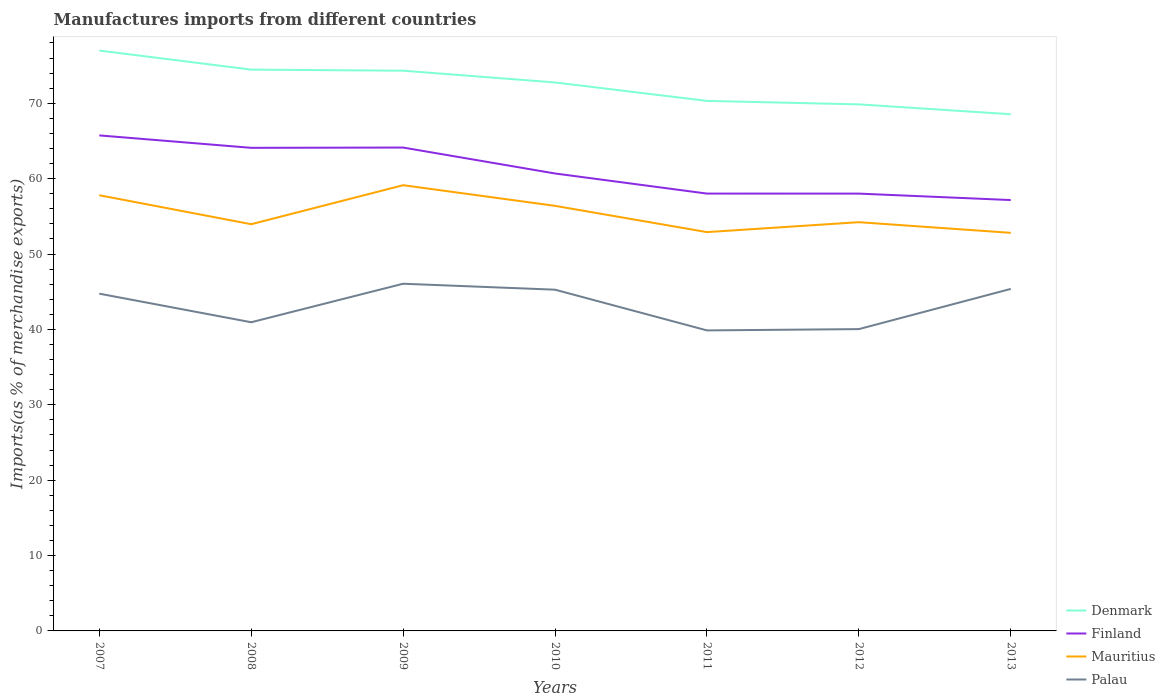Does the line corresponding to Denmark intersect with the line corresponding to Finland?
Provide a short and direct response. No. Across all years, what is the maximum percentage of imports to different countries in Denmark?
Your response must be concise. 68.54. What is the total percentage of imports to different countries in Palau in the graph?
Your answer should be compact. -5.11. What is the difference between the highest and the second highest percentage of imports to different countries in Finland?
Your response must be concise. 8.58. What is the difference between the highest and the lowest percentage of imports to different countries in Palau?
Make the answer very short. 4. Is the percentage of imports to different countries in Finland strictly greater than the percentage of imports to different countries in Mauritius over the years?
Provide a succinct answer. No. What is the difference between two consecutive major ticks on the Y-axis?
Offer a terse response. 10. Are the values on the major ticks of Y-axis written in scientific E-notation?
Offer a terse response. No. Does the graph contain grids?
Make the answer very short. No. How many legend labels are there?
Make the answer very short. 4. What is the title of the graph?
Provide a succinct answer. Manufactures imports from different countries. Does "Monaco" appear as one of the legend labels in the graph?
Offer a terse response. No. What is the label or title of the X-axis?
Your answer should be very brief. Years. What is the label or title of the Y-axis?
Your answer should be compact. Imports(as % of merchandise exports). What is the Imports(as % of merchandise exports) of Denmark in 2007?
Ensure brevity in your answer.  76.99. What is the Imports(as % of merchandise exports) in Finland in 2007?
Your answer should be very brief. 65.73. What is the Imports(as % of merchandise exports) in Mauritius in 2007?
Offer a terse response. 57.8. What is the Imports(as % of merchandise exports) of Palau in 2007?
Your response must be concise. 44.74. What is the Imports(as % of merchandise exports) in Denmark in 2008?
Ensure brevity in your answer.  74.46. What is the Imports(as % of merchandise exports) of Finland in 2008?
Ensure brevity in your answer.  64.08. What is the Imports(as % of merchandise exports) of Mauritius in 2008?
Offer a terse response. 53.95. What is the Imports(as % of merchandise exports) of Palau in 2008?
Ensure brevity in your answer.  40.95. What is the Imports(as % of merchandise exports) of Denmark in 2009?
Make the answer very short. 74.32. What is the Imports(as % of merchandise exports) in Finland in 2009?
Ensure brevity in your answer.  64.12. What is the Imports(as % of merchandise exports) in Mauritius in 2009?
Provide a short and direct response. 59.13. What is the Imports(as % of merchandise exports) in Palau in 2009?
Offer a terse response. 46.06. What is the Imports(as % of merchandise exports) in Denmark in 2010?
Your answer should be compact. 72.76. What is the Imports(as % of merchandise exports) of Finland in 2010?
Give a very brief answer. 60.68. What is the Imports(as % of merchandise exports) of Mauritius in 2010?
Offer a terse response. 56.39. What is the Imports(as % of merchandise exports) in Palau in 2010?
Make the answer very short. 45.27. What is the Imports(as % of merchandise exports) in Denmark in 2011?
Provide a succinct answer. 70.31. What is the Imports(as % of merchandise exports) in Finland in 2011?
Your answer should be very brief. 58.02. What is the Imports(as % of merchandise exports) of Mauritius in 2011?
Your answer should be very brief. 52.91. What is the Imports(as % of merchandise exports) in Palau in 2011?
Offer a terse response. 39.87. What is the Imports(as % of merchandise exports) in Denmark in 2012?
Make the answer very short. 69.85. What is the Imports(as % of merchandise exports) of Finland in 2012?
Your answer should be very brief. 58.01. What is the Imports(as % of merchandise exports) in Mauritius in 2012?
Give a very brief answer. 54.22. What is the Imports(as % of merchandise exports) in Palau in 2012?
Your response must be concise. 40.04. What is the Imports(as % of merchandise exports) of Denmark in 2013?
Offer a very short reply. 68.54. What is the Imports(as % of merchandise exports) in Finland in 2013?
Your answer should be compact. 57.16. What is the Imports(as % of merchandise exports) of Mauritius in 2013?
Provide a succinct answer. 52.81. What is the Imports(as % of merchandise exports) of Palau in 2013?
Make the answer very short. 45.37. Across all years, what is the maximum Imports(as % of merchandise exports) in Denmark?
Provide a succinct answer. 76.99. Across all years, what is the maximum Imports(as % of merchandise exports) in Finland?
Keep it short and to the point. 65.73. Across all years, what is the maximum Imports(as % of merchandise exports) of Mauritius?
Your answer should be very brief. 59.13. Across all years, what is the maximum Imports(as % of merchandise exports) of Palau?
Provide a succinct answer. 46.06. Across all years, what is the minimum Imports(as % of merchandise exports) in Denmark?
Your answer should be very brief. 68.54. Across all years, what is the minimum Imports(as % of merchandise exports) of Finland?
Give a very brief answer. 57.16. Across all years, what is the minimum Imports(as % of merchandise exports) of Mauritius?
Make the answer very short. 52.81. Across all years, what is the minimum Imports(as % of merchandise exports) in Palau?
Give a very brief answer. 39.87. What is the total Imports(as % of merchandise exports) of Denmark in the graph?
Offer a terse response. 507.23. What is the total Imports(as % of merchandise exports) in Finland in the graph?
Provide a short and direct response. 427.81. What is the total Imports(as % of merchandise exports) in Mauritius in the graph?
Offer a very short reply. 387.2. What is the total Imports(as % of merchandise exports) of Palau in the graph?
Offer a terse response. 302.28. What is the difference between the Imports(as % of merchandise exports) in Denmark in 2007 and that in 2008?
Your response must be concise. 2.53. What is the difference between the Imports(as % of merchandise exports) of Finland in 2007 and that in 2008?
Ensure brevity in your answer.  1.65. What is the difference between the Imports(as % of merchandise exports) of Mauritius in 2007 and that in 2008?
Offer a terse response. 3.84. What is the difference between the Imports(as % of merchandise exports) of Palau in 2007 and that in 2008?
Offer a terse response. 3.79. What is the difference between the Imports(as % of merchandise exports) in Denmark in 2007 and that in 2009?
Make the answer very short. 2.67. What is the difference between the Imports(as % of merchandise exports) in Finland in 2007 and that in 2009?
Keep it short and to the point. 1.61. What is the difference between the Imports(as % of merchandise exports) of Mauritius in 2007 and that in 2009?
Your answer should be very brief. -1.33. What is the difference between the Imports(as % of merchandise exports) of Palau in 2007 and that in 2009?
Your answer should be very brief. -1.32. What is the difference between the Imports(as % of merchandise exports) in Denmark in 2007 and that in 2010?
Provide a succinct answer. 4.23. What is the difference between the Imports(as % of merchandise exports) in Finland in 2007 and that in 2010?
Keep it short and to the point. 5.05. What is the difference between the Imports(as % of merchandise exports) in Mauritius in 2007 and that in 2010?
Ensure brevity in your answer.  1.41. What is the difference between the Imports(as % of merchandise exports) of Palau in 2007 and that in 2010?
Keep it short and to the point. -0.53. What is the difference between the Imports(as % of merchandise exports) in Denmark in 2007 and that in 2011?
Your answer should be compact. 6.68. What is the difference between the Imports(as % of merchandise exports) of Finland in 2007 and that in 2011?
Give a very brief answer. 7.72. What is the difference between the Imports(as % of merchandise exports) of Mauritius in 2007 and that in 2011?
Make the answer very short. 4.89. What is the difference between the Imports(as % of merchandise exports) of Palau in 2007 and that in 2011?
Give a very brief answer. 4.87. What is the difference between the Imports(as % of merchandise exports) in Denmark in 2007 and that in 2012?
Offer a very short reply. 7.14. What is the difference between the Imports(as % of merchandise exports) of Finland in 2007 and that in 2012?
Offer a terse response. 7.72. What is the difference between the Imports(as % of merchandise exports) in Mauritius in 2007 and that in 2012?
Provide a short and direct response. 3.57. What is the difference between the Imports(as % of merchandise exports) in Palau in 2007 and that in 2012?
Ensure brevity in your answer.  4.7. What is the difference between the Imports(as % of merchandise exports) of Denmark in 2007 and that in 2013?
Provide a short and direct response. 8.45. What is the difference between the Imports(as % of merchandise exports) of Finland in 2007 and that in 2013?
Ensure brevity in your answer.  8.58. What is the difference between the Imports(as % of merchandise exports) of Mauritius in 2007 and that in 2013?
Your answer should be very brief. 4.99. What is the difference between the Imports(as % of merchandise exports) of Palau in 2007 and that in 2013?
Provide a short and direct response. -0.63. What is the difference between the Imports(as % of merchandise exports) in Denmark in 2008 and that in 2009?
Offer a terse response. 0.14. What is the difference between the Imports(as % of merchandise exports) of Finland in 2008 and that in 2009?
Provide a short and direct response. -0.04. What is the difference between the Imports(as % of merchandise exports) of Mauritius in 2008 and that in 2009?
Provide a short and direct response. -5.18. What is the difference between the Imports(as % of merchandise exports) in Palau in 2008 and that in 2009?
Provide a succinct answer. -5.11. What is the difference between the Imports(as % of merchandise exports) in Denmark in 2008 and that in 2010?
Your answer should be compact. 1.7. What is the difference between the Imports(as % of merchandise exports) of Finland in 2008 and that in 2010?
Offer a very short reply. 3.4. What is the difference between the Imports(as % of merchandise exports) in Mauritius in 2008 and that in 2010?
Provide a succinct answer. -2.44. What is the difference between the Imports(as % of merchandise exports) of Palau in 2008 and that in 2010?
Offer a very short reply. -4.32. What is the difference between the Imports(as % of merchandise exports) of Denmark in 2008 and that in 2011?
Your answer should be very brief. 4.15. What is the difference between the Imports(as % of merchandise exports) of Finland in 2008 and that in 2011?
Provide a succinct answer. 6.07. What is the difference between the Imports(as % of merchandise exports) in Mauritius in 2008 and that in 2011?
Your answer should be compact. 1.05. What is the difference between the Imports(as % of merchandise exports) in Palau in 2008 and that in 2011?
Provide a short and direct response. 1.08. What is the difference between the Imports(as % of merchandise exports) in Denmark in 2008 and that in 2012?
Your response must be concise. 4.61. What is the difference between the Imports(as % of merchandise exports) in Finland in 2008 and that in 2012?
Ensure brevity in your answer.  6.07. What is the difference between the Imports(as % of merchandise exports) of Mauritius in 2008 and that in 2012?
Provide a short and direct response. -0.27. What is the difference between the Imports(as % of merchandise exports) of Palau in 2008 and that in 2012?
Provide a short and direct response. 0.91. What is the difference between the Imports(as % of merchandise exports) of Denmark in 2008 and that in 2013?
Your answer should be compact. 5.92. What is the difference between the Imports(as % of merchandise exports) of Finland in 2008 and that in 2013?
Offer a terse response. 6.93. What is the difference between the Imports(as % of merchandise exports) of Mauritius in 2008 and that in 2013?
Ensure brevity in your answer.  1.14. What is the difference between the Imports(as % of merchandise exports) of Palau in 2008 and that in 2013?
Your response must be concise. -4.42. What is the difference between the Imports(as % of merchandise exports) of Denmark in 2009 and that in 2010?
Your response must be concise. 1.56. What is the difference between the Imports(as % of merchandise exports) in Finland in 2009 and that in 2010?
Keep it short and to the point. 3.44. What is the difference between the Imports(as % of merchandise exports) of Mauritius in 2009 and that in 2010?
Provide a succinct answer. 2.74. What is the difference between the Imports(as % of merchandise exports) in Palau in 2009 and that in 2010?
Keep it short and to the point. 0.79. What is the difference between the Imports(as % of merchandise exports) in Denmark in 2009 and that in 2011?
Ensure brevity in your answer.  4.01. What is the difference between the Imports(as % of merchandise exports) of Finland in 2009 and that in 2011?
Offer a terse response. 6.11. What is the difference between the Imports(as % of merchandise exports) of Mauritius in 2009 and that in 2011?
Offer a very short reply. 6.22. What is the difference between the Imports(as % of merchandise exports) of Palau in 2009 and that in 2011?
Make the answer very short. 6.19. What is the difference between the Imports(as % of merchandise exports) of Denmark in 2009 and that in 2012?
Offer a terse response. 4.47. What is the difference between the Imports(as % of merchandise exports) in Finland in 2009 and that in 2012?
Your answer should be compact. 6.11. What is the difference between the Imports(as % of merchandise exports) of Mauritius in 2009 and that in 2012?
Make the answer very short. 4.91. What is the difference between the Imports(as % of merchandise exports) in Palau in 2009 and that in 2012?
Provide a short and direct response. 6.02. What is the difference between the Imports(as % of merchandise exports) in Denmark in 2009 and that in 2013?
Provide a succinct answer. 5.77. What is the difference between the Imports(as % of merchandise exports) of Finland in 2009 and that in 2013?
Make the answer very short. 6.97. What is the difference between the Imports(as % of merchandise exports) in Mauritius in 2009 and that in 2013?
Provide a succinct answer. 6.32. What is the difference between the Imports(as % of merchandise exports) in Palau in 2009 and that in 2013?
Offer a terse response. 0.69. What is the difference between the Imports(as % of merchandise exports) of Denmark in 2010 and that in 2011?
Your answer should be compact. 2.45. What is the difference between the Imports(as % of merchandise exports) in Finland in 2010 and that in 2011?
Your answer should be very brief. 2.67. What is the difference between the Imports(as % of merchandise exports) of Mauritius in 2010 and that in 2011?
Make the answer very short. 3.48. What is the difference between the Imports(as % of merchandise exports) of Palau in 2010 and that in 2011?
Ensure brevity in your answer.  5.4. What is the difference between the Imports(as % of merchandise exports) in Denmark in 2010 and that in 2012?
Offer a terse response. 2.91. What is the difference between the Imports(as % of merchandise exports) in Finland in 2010 and that in 2012?
Offer a very short reply. 2.67. What is the difference between the Imports(as % of merchandise exports) of Mauritius in 2010 and that in 2012?
Keep it short and to the point. 2.17. What is the difference between the Imports(as % of merchandise exports) in Palau in 2010 and that in 2012?
Ensure brevity in your answer.  5.23. What is the difference between the Imports(as % of merchandise exports) in Denmark in 2010 and that in 2013?
Provide a short and direct response. 4.22. What is the difference between the Imports(as % of merchandise exports) of Finland in 2010 and that in 2013?
Give a very brief answer. 3.53. What is the difference between the Imports(as % of merchandise exports) of Mauritius in 2010 and that in 2013?
Give a very brief answer. 3.58. What is the difference between the Imports(as % of merchandise exports) in Palau in 2010 and that in 2013?
Offer a very short reply. -0.1. What is the difference between the Imports(as % of merchandise exports) of Denmark in 2011 and that in 2012?
Provide a short and direct response. 0.46. What is the difference between the Imports(as % of merchandise exports) in Finland in 2011 and that in 2012?
Your answer should be very brief. 0. What is the difference between the Imports(as % of merchandise exports) of Mauritius in 2011 and that in 2012?
Your answer should be compact. -1.32. What is the difference between the Imports(as % of merchandise exports) of Palau in 2011 and that in 2012?
Provide a succinct answer. -0.17. What is the difference between the Imports(as % of merchandise exports) in Denmark in 2011 and that in 2013?
Your response must be concise. 1.77. What is the difference between the Imports(as % of merchandise exports) of Finland in 2011 and that in 2013?
Provide a succinct answer. 0.86. What is the difference between the Imports(as % of merchandise exports) in Mauritius in 2011 and that in 2013?
Your answer should be compact. 0.1. What is the difference between the Imports(as % of merchandise exports) of Palau in 2011 and that in 2013?
Your answer should be compact. -5.5. What is the difference between the Imports(as % of merchandise exports) of Denmark in 2012 and that in 2013?
Your answer should be compact. 1.31. What is the difference between the Imports(as % of merchandise exports) of Finland in 2012 and that in 2013?
Give a very brief answer. 0.85. What is the difference between the Imports(as % of merchandise exports) of Mauritius in 2012 and that in 2013?
Give a very brief answer. 1.41. What is the difference between the Imports(as % of merchandise exports) of Palau in 2012 and that in 2013?
Provide a short and direct response. -5.33. What is the difference between the Imports(as % of merchandise exports) of Denmark in 2007 and the Imports(as % of merchandise exports) of Finland in 2008?
Your response must be concise. 12.9. What is the difference between the Imports(as % of merchandise exports) in Denmark in 2007 and the Imports(as % of merchandise exports) in Mauritius in 2008?
Keep it short and to the point. 23.04. What is the difference between the Imports(as % of merchandise exports) of Denmark in 2007 and the Imports(as % of merchandise exports) of Palau in 2008?
Your answer should be compact. 36.04. What is the difference between the Imports(as % of merchandise exports) in Finland in 2007 and the Imports(as % of merchandise exports) in Mauritius in 2008?
Keep it short and to the point. 11.78. What is the difference between the Imports(as % of merchandise exports) in Finland in 2007 and the Imports(as % of merchandise exports) in Palau in 2008?
Offer a terse response. 24.79. What is the difference between the Imports(as % of merchandise exports) in Mauritius in 2007 and the Imports(as % of merchandise exports) in Palau in 2008?
Offer a terse response. 16.85. What is the difference between the Imports(as % of merchandise exports) of Denmark in 2007 and the Imports(as % of merchandise exports) of Finland in 2009?
Your response must be concise. 12.86. What is the difference between the Imports(as % of merchandise exports) in Denmark in 2007 and the Imports(as % of merchandise exports) in Mauritius in 2009?
Keep it short and to the point. 17.86. What is the difference between the Imports(as % of merchandise exports) of Denmark in 2007 and the Imports(as % of merchandise exports) of Palau in 2009?
Provide a short and direct response. 30.93. What is the difference between the Imports(as % of merchandise exports) in Finland in 2007 and the Imports(as % of merchandise exports) in Mauritius in 2009?
Your answer should be very brief. 6.61. What is the difference between the Imports(as % of merchandise exports) of Finland in 2007 and the Imports(as % of merchandise exports) of Palau in 2009?
Keep it short and to the point. 19.68. What is the difference between the Imports(as % of merchandise exports) in Mauritius in 2007 and the Imports(as % of merchandise exports) in Palau in 2009?
Make the answer very short. 11.74. What is the difference between the Imports(as % of merchandise exports) of Denmark in 2007 and the Imports(as % of merchandise exports) of Finland in 2010?
Your response must be concise. 16.31. What is the difference between the Imports(as % of merchandise exports) of Denmark in 2007 and the Imports(as % of merchandise exports) of Mauritius in 2010?
Give a very brief answer. 20.6. What is the difference between the Imports(as % of merchandise exports) in Denmark in 2007 and the Imports(as % of merchandise exports) in Palau in 2010?
Give a very brief answer. 31.72. What is the difference between the Imports(as % of merchandise exports) in Finland in 2007 and the Imports(as % of merchandise exports) in Mauritius in 2010?
Provide a short and direct response. 9.34. What is the difference between the Imports(as % of merchandise exports) of Finland in 2007 and the Imports(as % of merchandise exports) of Palau in 2010?
Ensure brevity in your answer.  20.47. What is the difference between the Imports(as % of merchandise exports) of Mauritius in 2007 and the Imports(as % of merchandise exports) of Palau in 2010?
Offer a terse response. 12.53. What is the difference between the Imports(as % of merchandise exports) of Denmark in 2007 and the Imports(as % of merchandise exports) of Finland in 2011?
Make the answer very short. 18.97. What is the difference between the Imports(as % of merchandise exports) of Denmark in 2007 and the Imports(as % of merchandise exports) of Mauritius in 2011?
Give a very brief answer. 24.08. What is the difference between the Imports(as % of merchandise exports) in Denmark in 2007 and the Imports(as % of merchandise exports) in Palau in 2011?
Your answer should be compact. 37.12. What is the difference between the Imports(as % of merchandise exports) in Finland in 2007 and the Imports(as % of merchandise exports) in Mauritius in 2011?
Provide a succinct answer. 12.83. What is the difference between the Imports(as % of merchandise exports) in Finland in 2007 and the Imports(as % of merchandise exports) in Palau in 2011?
Offer a very short reply. 25.87. What is the difference between the Imports(as % of merchandise exports) of Mauritius in 2007 and the Imports(as % of merchandise exports) of Palau in 2011?
Your answer should be compact. 17.93. What is the difference between the Imports(as % of merchandise exports) in Denmark in 2007 and the Imports(as % of merchandise exports) in Finland in 2012?
Ensure brevity in your answer.  18.98. What is the difference between the Imports(as % of merchandise exports) of Denmark in 2007 and the Imports(as % of merchandise exports) of Mauritius in 2012?
Keep it short and to the point. 22.77. What is the difference between the Imports(as % of merchandise exports) of Denmark in 2007 and the Imports(as % of merchandise exports) of Palau in 2012?
Your answer should be compact. 36.95. What is the difference between the Imports(as % of merchandise exports) of Finland in 2007 and the Imports(as % of merchandise exports) of Mauritius in 2012?
Your answer should be compact. 11.51. What is the difference between the Imports(as % of merchandise exports) of Finland in 2007 and the Imports(as % of merchandise exports) of Palau in 2012?
Your answer should be very brief. 25.7. What is the difference between the Imports(as % of merchandise exports) of Mauritius in 2007 and the Imports(as % of merchandise exports) of Palau in 2012?
Provide a short and direct response. 17.76. What is the difference between the Imports(as % of merchandise exports) of Denmark in 2007 and the Imports(as % of merchandise exports) of Finland in 2013?
Your answer should be very brief. 19.83. What is the difference between the Imports(as % of merchandise exports) of Denmark in 2007 and the Imports(as % of merchandise exports) of Mauritius in 2013?
Your answer should be very brief. 24.18. What is the difference between the Imports(as % of merchandise exports) in Denmark in 2007 and the Imports(as % of merchandise exports) in Palau in 2013?
Make the answer very short. 31.62. What is the difference between the Imports(as % of merchandise exports) in Finland in 2007 and the Imports(as % of merchandise exports) in Mauritius in 2013?
Provide a succinct answer. 12.93. What is the difference between the Imports(as % of merchandise exports) in Finland in 2007 and the Imports(as % of merchandise exports) in Palau in 2013?
Your answer should be compact. 20.36. What is the difference between the Imports(as % of merchandise exports) of Mauritius in 2007 and the Imports(as % of merchandise exports) of Palau in 2013?
Offer a very short reply. 12.42. What is the difference between the Imports(as % of merchandise exports) of Denmark in 2008 and the Imports(as % of merchandise exports) of Finland in 2009?
Offer a terse response. 10.34. What is the difference between the Imports(as % of merchandise exports) in Denmark in 2008 and the Imports(as % of merchandise exports) in Mauritius in 2009?
Provide a short and direct response. 15.33. What is the difference between the Imports(as % of merchandise exports) in Denmark in 2008 and the Imports(as % of merchandise exports) in Palau in 2009?
Make the answer very short. 28.4. What is the difference between the Imports(as % of merchandise exports) in Finland in 2008 and the Imports(as % of merchandise exports) in Mauritius in 2009?
Offer a very short reply. 4.96. What is the difference between the Imports(as % of merchandise exports) of Finland in 2008 and the Imports(as % of merchandise exports) of Palau in 2009?
Give a very brief answer. 18.03. What is the difference between the Imports(as % of merchandise exports) of Mauritius in 2008 and the Imports(as % of merchandise exports) of Palau in 2009?
Your answer should be very brief. 7.9. What is the difference between the Imports(as % of merchandise exports) of Denmark in 2008 and the Imports(as % of merchandise exports) of Finland in 2010?
Your response must be concise. 13.78. What is the difference between the Imports(as % of merchandise exports) of Denmark in 2008 and the Imports(as % of merchandise exports) of Mauritius in 2010?
Give a very brief answer. 18.07. What is the difference between the Imports(as % of merchandise exports) of Denmark in 2008 and the Imports(as % of merchandise exports) of Palau in 2010?
Offer a terse response. 29.19. What is the difference between the Imports(as % of merchandise exports) in Finland in 2008 and the Imports(as % of merchandise exports) in Mauritius in 2010?
Offer a terse response. 7.7. What is the difference between the Imports(as % of merchandise exports) in Finland in 2008 and the Imports(as % of merchandise exports) in Palau in 2010?
Give a very brief answer. 18.82. What is the difference between the Imports(as % of merchandise exports) in Mauritius in 2008 and the Imports(as % of merchandise exports) in Palau in 2010?
Your answer should be compact. 8.69. What is the difference between the Imports(as % of merchandise exports) in Denmark in 2008 and the Imports(as % of merchandise exports) in Finland in 2011?
Your response must be concise. 16.45. What is the difference between the Imports(as % of merchandise exports) of Denmark in 2008 and the Imports(as % of merchandise exports) of Mauritius in 2011?
Give a very brief answer. 21.56. What is the difference between the Imports(as % of merchandise exports) in Denmark in 2008 and the Imports(as % of merchandise exports) in Palau in 2011?
Your answer should be compact. 34.59. What is the difference between the Imports(as % of merchandise exports) of Finland in 2008 and the Imports(as % of merchandise exports) of Mauritius in 2011?
Offer a very short reply. 11.18. What is the difference between the Imports(as % of merchandise exports) of Finland in 2008 and the Imports(as % of merchandise exports) of Palau in 2011?
Your response must be concise. 24.22. What is the difference between the Imports(as % of merchandise exports) of Mauritius in 2008 and the Imports(as % of merchandise exports) of Palau in 2011?
Offer a very short reply. 14.09. What is the difference between the Imports(as % of merchandise exports) of Denmark in 2008 and the Imports(as % of merchandise exports) of Finland in 2012?
Your answer should be very brief. 16.45. What is the difference between the Imports(as % of merchandise exports) in Denmark in 2008 and the Imports(as % of merchandise exports) in Mauritius in 2012?
Offer a terse response. 20.24. What is the difference between the Imports(as % of merchandise exports) of Denmark in 2008 and the Imports(as % of merchandise exports) of Palau in 2012?
Your answer should be very brief. 34.42. What is the difference between the Imports(as % of merchandise exports) of Finland in 2008 and the Imports(as % of merchandise exports) of Mauritius in 2012?
Make the answer very short. 9.86. What is the difference between the Imports(as % of merchandise exports) of Finland in 2008 and the Imports(as % of merchandise exports) of Palau in 2012?
Offer a very short reply. 24.05. What is the difference between the Imports(as % of merchandise exports) in Mauritius in 2008 and the Imports(as % of merchandise exports) in Palau in 2012?
Offer a terse response. 13.92. What is the difference between the Imports(as % of merchandise exports) in Denmark in 2008 and the Imports(as % of merchandise exports) in Finland in 2013?
Provide a short and direct response. 17.3. What is the difference between the Imports(as % of merchandise exports) in Denmark in 2008 and the Imports(as % of merchandise exports) in Mauritius in 2013?
Your response must be concise. 21.65. What is the difference between the Imports(as % of merchandise exports) of Denmark in 2008 and the Imports(as % of merchandise exports) of Palau in 2013?
Offer a very short reply. 29.09. What is the difference between the Imports(as % of merchandise exports) in Finland in 2008 and the Imports(as % of merchandise exports) in Mauritius in 2013?
Provide a succinct answer. 11.28. What is the difference between the Imports(as % of merchandise exports) in Finland in 2008 and the Imports(as % of merchandise exports) in Palau in 2013?
Offer a terse response. 18.71. What is the difference between the Imports(as % of merchandise exports) in Mauritius in 2008 and the Imports(as % of merchandise exports) in Palau in 2013?
Offer a terse response. 8.58. What is the difference between the Imports(as % of merchandise exports) in Denmark in 2009 and the Imports(as % of merchandise exports) in Finland in 2010?
Offer a terse response. 13.63. What is the difference between the Imports(as % of merchandise exports) in Denmark in 2009 and the Imports(as % of merchandise exports) in Mauritius in 2010?
Your answer should be very brief. 17.93. What is the difference between the Imports(as % of merchandise exports) in Denmark in 2009 and the Imports(as % of merchandise exports) in Palau in 2010?
Your response must be concise. 29.05. What is the difference between the Imports(as % of merchandise exports) of Finland in 2009 and the Imports(as % of merchandise exports) of Mauritius in 2010?
Make the answer very short. 7.73. What is the difference between the Imports(as % of merchandise exports) of Finland in 2009 and the Imports(as % of merchandise exports) of Palau in 2010?
Keep it short and to the point. 18.86. What is the difference between the Imports(as % of merchandise exports) of Mauritius in 2009 and the Imports(as % of merchandise exports) of Palau in 2010?
Provide a succinct answer. 13.86. What is the difference between the Imports(as % of merchandise exports) in Denmark in 2009 and the Imports(as % of merchandise exports) in Finland in 2011?
Offer a terse response. 16.3. What is the difference between the Imports(as % of merchandise exports) of Denmark in 2009 and the Imports(as % of merchandise exports) of Mauritius in 2011?
Offer a terse response. 21.41. What is the difference between the Imports(as % of merchandise exports) of Denmark in 2009 and the Imports(as % of merchandise exports) of Palau in 2011?
Ensure brevity in your answer.  34.45. What is the difference between the Imports(as % of merchandise exports) of Finland in 2009 and the Imports(as % of merchandise exports) of Mauritius in 2011?
Provide a succinct answer. 11.22. What is the difference between the Imports(as % of merchandise exports) of Finland in 2009 and the Imports(as % of merchandise exports) of Palau in 2011?
Offer a very short reply. 24.26. What is the difference between the Imports(as % of merchandise exports) in Mauritius in 2009 and the Imports(as % of merchandise exports) in Palau in 2011?
Offer a very short reply. 19.26. What is the difference between the Imports(as % of merchandise exports) of Denmark in 2009 and the Imports(as % of merchandise exports) of Finland in 2012?
Offer a very short reply. 16.3. What is the difference between the Imports(as % of merchandise exports) in Denmark in 2009 and the Imports(as % of merchandise exports) in Mauritius in 2012?
Ensure brevity in your answer.  20.09. What is the difference between the Imports(as % of merchandise exports) of Denmark in 2009 and the Imports(as % of merchandise exports) of Palau in 2012?
Ensure brevity in your answer.  34.28. What is the difference between the Imports(as % of merchandise exports) of Finland in 2009 and the Imports(as % of merchandise exports) of Mauritius in 2012?
Make the answer very short. 9.9. What is the difference between the Imports(as % of merchandise exports) in Finland in 2009 and the Imports(as % of merchandise exports) in Palau in 2012?
Make the answer very short. 24.09. What is the difference between the Imports(as % of merchandise exports) of Mauritius in 2009 and the Imports(as % of merchandise exports) of Palau in 2012?
Provide a short and direct response. 19.09. What is the difference between the Imports(as % of merchandise exports) of Denmark in 2009 and the Imports(as % of merchandise exports) of Finland in 2013?
Ensure brevity in your answer.  17.16. What is the difference between the Imports(as % of merchandise exports) of Denmark in 2009 and the Imports(as % of merchandise exports) of Mauritius in 2013?
Offer a terse response. 21.51. What is the difference between the Imports(as % of merchandise exports) of Denmark in 2009 and the Imports(as % of merchandise exports) of Palau in 2013?
Ensure brevity in your answer.  28.95. What is the difference between the Imports(as % of merchandise exports) of Finland in 2009 and the Imports(as % of merchandise exports) of Mauritius in 2013?
Your response must be concise. 11.31. What is the difference between the Imports(as % of merchandise exports) of Finland in 2009 and the Imports(as % of merchandise exports) of Palau in 2013?
Your response must be concise. 18.75. What is the difference between the Imports(as % of merchandise exports) in Mauritius in 2009 and the Imports(as % of merchandise exports) in Palau in 2013?
Ensure brevity in your answer.  13.76. What is the difference between the Imports(as % of merchandise exports) of Denmark in 2010 and the Imports(as % of merchandise exports) of Finland in 2011?
Provide a succinct answer. 14.74. What is the difference between the Imports(as % of merchandise exports) in Denmark in 2010 and the Imports(as % of merchandise exports) in Mauritius in 2011?
Your answer should be compact. 19.85. What is the difference between the Imports(as % of merchandise exports) in Denmark in 2010 and the Imports(as % of merchandise exports) in Palau in 2011?
Keep it short and to the point. 32.89. What is the difference between the Imports(as % of merchandise exports) in Finland in 2010 and the Imports(as % of merchandise exports) in Mauritius in 2011?
Give a very brief answer. 7.78. What is the difference between the Imports(as % of merchandise exports) of Finland in 2010 and the Imports(as % of merchandise exports) of Palau in 2011?
Offer a terse response. 20.82. What is the difference between the Imports(as % of merchandise exports) of Mauritius in 2010 and the Imports(as % of merchandise exports) of Palau in 2011?
Make the answer very short. 16.52. What is the difference between the Imports(as % of merchandise exports) of Denmark in 2010 and the Imports(as % of merchandise exports) of Finland in 2012?
Your response must be concise. 14.75. What is the difference between the Imports(as % of merchandise exports) of Denmark in 2010 and the Imports(as % of merchandise exports) of Mauritius in 2012?
Your answer should be very brief. 18.54. What is the difference between the Imports(as % of merchandise exports) of Denmark in 2010 and the Imports(as % of merchandise exports) of Palau in 2012?
Give a very brief answer. 32.72. What is the difference between the Imports(as % of merchandise exports) in Finland in 2010 and the Imports(as % of merchandise exports) in Mauritius in 2012?
Provide a short and direct response. 6.46. What is the difference between the Imports(as % of merchandise exports) in Finland in 2010 and the Imports(as % of merchandise exports) in Palau in 2012?
Provide a short and direct response. 20.65. What is the difference between the Imports(as % of merchandise exports) in Mauritius in 2010 and the Imports(as % of merchandise exports) in Palau in 2012?
Keep it short and to the point. 16.35. What is the difference between the Imports(as % of merchandise exports) in Denmark in 2010 and the Imports(as % of merchandise exports) in Finland in 2013?
Offer a very short reply. 15.6. What is the difference between the Imports(as % of merchandise exports) in Denmark in 2010 and the Imports(as % of merchandise exports) in Mauritius in 2013?
Provide a succinct answer. 19.95. What is the difference between the Imports(as % of merchandise exports) of Denmark in 2010 and the Imports(as % of merchandise exports) of Palau in 2013?
Provide a succinct answer. 27.39. What is the difference between the Imports(as % of merchandise exports) of Finland in 2010 and the Imports(as % of merchandise exports) of Mauritius in 2013?
Make the answer very short. 7.87. What is the difference between the Imports(as % of merchandise exports) in Finland in 2010 and the Imports(as % of merchandise exports) in Palau in 2013?
Offer a very short reply. 15.31. What is the difference between the Imports(as % of merchandise exports) of Mauritius in 2010 and the Imports(as % of merchandise exports) of Palau in 2013?
Ensure brevity in your answer.  11.02. What is the difference between the Imports(as % of merchandise exports) of Denmark in 2011 and the Imports(as % of merchandise exports) of Finland in 2012?
Ensure brevity in your answer.  12.3. What is the difference between the Imports(as % of merchandise exports) of Denmark in 2011 and the Imports(as % of merchandise exports) of Mauritius in 2012?
Provide a succinct answer. 16.09. What is the difference between the Imports(as % of merchandise exports) of Denmark in 2011 and the Imports(as % of merchandise exports) of Palau in 2012?
Your answer should be compact. 30.27. What is the difference between the Imports(as % of merchandise exports) in Finland in 2011 and the Imports(as % of merchandise exports) in Mauritius in 2012?
Give a very brief answer. 3.79. What is the difference between the Imports(as % of merchandise exports) in Finland in 2011 and the Imports(as % of merchandise exports) in Palau in 2012?
Offer a very short reply. 17.98. What is the difference between the Imports(as % of merchandise exports) in Mauritius in 2011 and the Imports(as % of merchandise exports) in Palau in 2012?
Your answer should be compact. 12.87. What is the difference between the Imports(as % of merchandise exports) in Denmark in 2011 and the Imports(as % of merchandise exports) in Finland in 2013?
Your response must be concise. 13.15. What is the difference between the Imports(as % of merchandise exports) in Denmark in 2011 and the Imports(as % of merchandise exports) in Mauritius in 2013?
Your response must be concise. 17.5. What is the difference between the Imports(as % of merchandise exports) in Denmark in 2011 and the Imports(as % of merchandise exports) in Palau in 2013?
Offer a very short reply. 24.94. What is the difference between the Imports(as % of merchandise exports) of Finland in 2011 and the Imports(as % of merchandise exports) of Mauritius in 2013?
Ensure brevity in your answer.  5.21. What is the difference between the Imports(as % of merchandise exports) of Finland in 2011 and the Imports(as % of merchandise exports) of Palau in 2013?
Offer a very short reply. 12.64. What is the difference between the Imports(as % of merchandise exports) of Mauritius in 2011 and the Imports(as % of merchandise exports) of Palau in 2013?
Offer a very short reply. 7.53. What is the difference between the Imports(as % of merchandise exports) in Denmark in 2012 and the Imports(as % of merchandise exports) in Finland in 2013?
Offer a terse response. 12.69. What is the difference between the Imports(as % of merchandise exports) of Denmark in 2012 and the Imports(as % of merchandise exports) of Mauritius in 2013?
Ensure brevity in your answer.  17.04. What is the difference between the Imports(as % of merchandise exports) of Denmark in 2012 and the Imports(as % of merchandise exports) of Palau in 2013?
Provide a succinct answer. 24.48. What is the difference between the Imports(as % of merchandise exports) in Finland in 2012 and the Imports(as % of merchandise exports) in Mauritius in 2013?
Ensure brevity in your answer.  5.2. What is the difference between the Imports(as % of merchandise exports) of Finland in 2012 and the Imports(as % of merchandise exports) of Palau in 2013?
Provide a succinct answer. 12.64. What is the difference between the Imports(as % of merchandise exports) of Mauritius in 2012 and the Imports(as % of merchandise exports) of Palau in 2013?
Give a very brief answer. 8.85. What is the average Imports(as % of merchandise exports) of Denmark per year?
Your answer should be very brief. 72.46. What is the average Imports(as % of merchandise exports) in Finland per year?
Your response must be concise. 61.12. What is the average Imports(as % of merchandise exports) of Mauritius per year?
Your answer should be compact. 55.31. What is the average Imports(as % of merchandise exports) in Palau per year?
Make the answer very short. 43.18. In the year 2007, what is the difference between the Imports(as % of merchandise exports) of Denmark and Imports(as % of merchandise exports) of Finland?
Your answer should be very brief. 11.25. In the year 2007, what is the difference between the Imports(as % of merchandise exports) of Denmark and Imports(as % of merchandise exports) of Mauritius?
Offer a very short reply. 19.19. In the year 2007, what is the difference between the Imports(as % of merchandise exports) of Denmark and Imports(as % of merchandise exports) of Palau?
Provide a short and direct response. 32.25. In the year 2007, what is the difference between the Imports(as % of merchandise exports) in Finland and Imports(as % of merchandise exports) in Mauritius?
Give a very brief answer. 7.94. In the year 2007, what is the difference between the Imports(as % of merchandise exports) of Finland and Imports(as % of merchandise exports) of Palau?
Give a very brief answer. 20.99. In the year 2007, what is the difference between the Imports(as % of merchandise exports) of Mauritius and Imports(as % of merchandise exports) of Palau?
Keep it short and to the point. 13.06. In the year 2008, what is the difference between the Imports(as % of merchandise exports) of Denmark and Imports(as % of merchandise exports) of Finland?
Your response must be concise. 10.38. In the year 2008, what is the difference between the Imports(as % of merchandise exports) in Denmark and Imports(as % of merchandise exports) in Mauritius?
Provide a short and direct response. 20.51. In the year 2008, what is the difference between the Imports(as % of merchandise exports) in Denmark and Imports(as % of merchandise exports) in Palau?
Ensure brevity in your answer.  33.51. In the year 2008, what is the difference between the Imports(as % of merchandise exports) in Finland and Imports(as % of merchandise exports) in Mauritius?
Ensure brevity in your answer.  10.13. In the year 2008, what is the difference between the Imports(as % of merchandise exports) of Finland and Imports(as % of merchandise exports) of Palau?
Ensure brevity in your answer.  23.14. In the year 2008, what is the difference between the Imports(as % of merchandise exports) in Mauritius and Imports(as % of merchandise exports) in Palau?
Offer a very short reply. 13.01. In the year 2009, what is the difference between the Imports(as % of merchandise exports) of Denmark and Imports(as % of merchandise exports) of Finland?
Make the answer very short. 10.19. In the year 2009, what is the difference between the Imports(as % of merchandise exports) of Denmark and Imports(as % of merchandise exports) of Mauritius?
Provide a short and direct response. 15.19. In the year 2009, what is the difference between the Imports(as % of merchandise exports) of Denmark and Imports(as % of merchandise exports) of Palau?
Your answer should be compact. 28.26. In the year 2009, what is the difference between the Imports(as % of merchandise exports) in Finland and Imports(as % of merchandise exports) in Mauritius?
Offer a terse response. 4.99. In the year 2009, what is the difference between the Imports(as % of merchandise exports) of Finland and Imports(as % of merchandise exports) of Palau?
Offer a terse response. 18.07. In the year 2009, what is the difference between the Imports(as % of merchandise exports) in Mauritius and Imports(as % of merchandise exports) in Palau?
Make the answer very short. 13.07. In the year 2010, what is the difference between the Imports(as % of merchandise exports) of Denmark and Imports(as % of merchandise exports) of Finland?
Make the answer very short. 12.08. In the year 2010, what is the difference between the Imports(as % of merchandise exports) in Denmark and Imports(as % of merchandise exports) in Mauritius?
Keep it short and to the point. 16.37. In the year 2010, what is the difference between the Imports(as % of merchandise exports) of Denmark and Imports(as % of merchandise exports) of Palau?
Keep it short and to the point. 27.49. In the year 2010, what is the difference between the Imports(as % of merchandise exports) of Finland and Imports(as % of merchandise exports) of Mauritius?
Provide a succinct answer. 4.29. In the year 2010, what is the difference between the Imports(as % of merchandise exports) of Finland and Imports(as % of merchandise exports) of Palau?
Offer a terse response. 15.42. In the year 2010, what is the difference between the Imports(as % of merchandise exports) in Mauritius and Imports(as % of merchandise exports) in Palau?
Your answer should be very brief. 11.12. In the year 2011, what is the difference between the Imports(as % of merchandise exports) of Denmark and Imports(as % of merchandise exports) of Finland?
Give a very brief answer. 12.29. In the year 2011, what is the difference between the Imports(as % of merchandise exports) of Denmark and Imports(as % of merchandise exports) of Mauritius?
Keep it short and to the point. 17.41. In the year 2011, what is the difference between the Imports(as % of merchandise exports) of Denmark and Imports(as % of merchandise exports) of Palau?
Provide a succinct answer. 30.44. In the year 2011, what is the difference between the Imports(as % of merchandise exports) in Finland and Imports(as % of merchandise exports) in Mauritius?
Make the answer very short. 5.11. In the year 2011, what is the difference between the Imports(as % of merchandise exports) in Finland and Imports(as % of merchandise exports) in Palau?
Give a very brief answer. 18.15. In the year 2011, what is the difference between the Imports(as % of merchandise exports) in Mauritius and Imports(as % of merchandise exports) in Palau?
Give a very brief answer. 13.04. In the year 2012, what is the difference between the Imports(as % of merchandise exports) of Denmark and Imports(as % of merchandise exports) of Finland?
Your response must be concise. 11.84. In the year 2012, what is the difference between the Imports(as % of merchandise exports) of Denmark and Imports(as % of merchandise exports) of Mauritius?
Offer a very short reply. 15.63. In the year 2012, what is the difference between the Imports(as % of merchandise exports) of Denmark and Imports(as % of merchandise exports) of Palau?
Make the answer very short. 29.81. In the year 2012, what is the difference between the Imports(as % of merchandise exports) of Finland and Imports(as % of merchandise exports) of Mauritius?
Offer a terse response. 3.79. In the year 2012, what is the difference between the Imports(as % of merchandise exports) of Finland and Imports(as % of merchandise exports) of Palau?
Keep it short and to the point. 17.98. In the year 2012, what is the difference between the Imports(as % of merchandise exports) in Mauritius and Imports(as % of merchandise exports) in Palau?
Your answer should be compact. 14.19. In the year 2013, what is the difference between the Imports(as % of merchandise exports) of Denmark and Imports(as % of merchandise exports) of Finland?
Your answer should be compact. 11.38. In the year 2013, what is the difference between the Imports(as % of merchandise exports) of Denmark and Imports(as % of merchandise exports) of Mauritius?
Your response must be concise. 15.73. In the year 2013, what is the difference between the Imports(as % of merchandise exports) of Denmark and Imports(as % of merchandise exports) of Palau?
Provide a short and direct response. 23.17. In the year 2013, what is the difference between the Imports(as % of merchandise exports) in Finland and Imports(as % of merchandise exports) in Mauritius?
Provide a succinct answer. 4.35. In the year 2013, what is the difference between the Imports(as % of merchandise exports) in Finland and Imports(as % of merchandise exports) in Palau?
Keep it short and to the point. 11.79. In the year 2013, what is the difference between the Imports(as % of merchandise exports) in Mauritius and Imports(as % of merchandise exports) in Palau?
Ensure brevity in your answer.  7.44. What is the ratio of the Imports(as % of merchandise exports) of Denmark in 2007 to that in 2008?
Your answer should be compact. 1.03. What is the ratio of the Imports(as % of merchandise exports) of Finland in 2007 to that in 2008?
Your answer should be compact. 1.03. What is the ratio of the Imports(as % of merchandise exports) in Mauritius in 2007 to that in 2008?
Offer a very short reply. 1.07. What is the ratio of the Imports(as % of merchandise exports) in Palau in 2007 to that in 2008?
Your response must be concise. 1.09. What is the ratio of the Imports(as % of merchandise exports) of Denmark in 2007 to that in 2009?
Your answer should be compact. 1.04. What is the ratio of the Imports(as % of merchandise exports) in Finland in 2007 to that in 2009?
Ensure brevity in your answer.  1.03. What is the ratio of the Imports(as % of merchandise exports) of Mauritius in 2007 to that in 2009?
Offer a terse response. 0.98. What is the ratio of the Imports(as % of merchandise exports) in Palau in 2007 to that in 2009?
Make the answer very short. 0.97. What is the ratio of the Imports(as % of merchandise exports) in Denmark in 2007 to that in 2010?
Ensure brevity in your answer.  1.06. What is the ratio of the Imports(as % of merchandise exports) in Finland in 2007 to that in 2010?
Provide a short and direct response. 1.08. What is the ratio of the Imports(as % of merchandise exports) in Mauritius in 2007 to that in 2010?
Your response must be concise. 1.02. What is the ratio of the Imports(as % of merchandise exports) of Palau in 2007 to that in 2010?
Keep it short and to the point. 0.99. What is the ratio of the Imports(as % of merchandise exports) of Denmark in 2007 to that in 2011?
Keep it short and to the point. 1.09. What is the ratio of the Imports(as % of merchandise exports) in Finland in 2007 to that in 2011?
Give a very brief answer. 1.13. What is the ratio of the Imports(as % of merchandise exports) of Mauritius in 2007 to that in 2011?
Your response must be concise. 1.09. What is the ratio of the Imports(as % of merchandise exports) in Palau in 2007 to that in 2011?
Your answer should be compact. 1.12. What is the ratio of the Imports(as % of merchandise exports) in Denmark in 2007 to that in 2012?
Keep it short and to the point. 1.1. What is the ratio of the Imports(as % of merchandise exports) of Finland in 2007 to that in 2012?
Offer a terse response. 1.13. What is the ratio of the Imports(as % of merchandise exports) in Mauritius in 2007 to that in 2012?
Your answer should be very brief. 1.07. What is the ratio of the Imports(as % of merchandise exports) in Palau in 2007 to that in 2012?
Your answer should be compact. 1.12. What is the ratio of the Imports(as % of merchandise exports) in Denmark in 2007 to that in 2013?
Offer a very short reply. 1.12. What is the ratio of the Imports(as % of merchandise exports) of Finland in 2007 to that in 2013?
Offer a terse response. 1.15. What is the ratio of the Imports(as % of merchandise exports) of Mauritius in 2007 to that in 2013?
Give a very brief answer. 1.09. What is the ratio of the Imports(as % of merchandise exports) of Palau in 2007 to that in 2013?
Offer a terse response. 0.99. What is the ratio of the Imports(as % of merchandise exports) in Denmark in 2008 to that in 2009?
Ensure brevity in your answer.  1. What is the ratio of the Imports(as % of merchandise exports) of Mauritius in 2008 to that in 2009?
Provide a short and direct response. 0.91. What is the ratio of the Imports(as % of merchandise exports) of Palau in 2008 to that in 2009?
Your answer should be very brief. 0.89. What is the ratio of the Imports(as % of merchandise exports) in Denmark in 2008 to that in 2010?
Make the answer very short. 1.02. What is the ratio of the Imports(as % of merchandise exports) of Finland in 2008 to that in 2010?
Your response must be concise. 1.06. What is the ratio of the Imports(as % of merchandise exports) in Mauritius in 2008 to that in 2010?
Your answer should be compact. 0.96. What is the ratio of the Imports(as % of merchandise exports) in Palau in 2008 to that in 2010?
Your answer should be very brief. 0.9. What is the ratio of the Imports(as % of merchandise exports) in Denmark in 2008 to that in 2011?
Offer a very short reply. 1.06. What is the ratio of the Imports(as % of merchandise exports) of Finland in 2008 to that in 2011?
Your answer should be very brief. 1.1. What is the ratio of the Imports(as % of merchandise exports) in Mauritius in 2008 to that in 2011?
Your response must be concise. 1.02. What is the ratio of the Imports(as % of merchandise exports) in Palau in 2008 to that in 2011?
Offer a very short reply. 1.03. What is the ratio of the Imports(as % of merchandise exports) of Denmark in 2008 to that in 2012?
Keep it short and to the point. 1.07. What is the ratio of the Imports(as % of merchandise exports) of Finland in 2008 to that in 2012?
Give a very brief answer. 1.1. What is the ratio of the Imports(as % of merchandise exports) in Palau in 2008 to that in 2012?
Keep it short and to the point. 1.02. What is the ratio of the Imports(as % of merchandise exports) of Denmark in 2008 to that in 2013?
Give a very brief answer. 1.09. What is the ratio of the Imports(as % of merchandise exports) of Finland in 2008 to that in 2013?
Give a very brief answer. 1.12. What is the ratio of the Imports(as % of merchandise exports) in Mauritius in 2008 to that in 2013?
Your answer should be very brief. 1.02. What is the ratio of the Imports(as % of merchandise exports) in Palau in 2008 to that in 2013?
Your answer should be very brief. 0.9. What is the ratio of the Imports(as % of merchandise exports) in Denmark in 2009 to that in 2010?
Offer a very short reply. 1.02. What is the ratio of the Imports(as % of merchandise exports) of Finland in 2009 to that in 2010?
Keep it short and to the point. 1.06. What is the ratio of the Imports(as % of merchandise exports) in Mauritius in 2009 to that in 2010?
Offer a terse response. 1.05. What is the ratio of the Imports(as % of merchandise exports) in Palau in 2009 to that in 2010?
Your answer should be very brief. 1.02. What is the ratio of the Imports(as % of merchandise exports) in Denmark in 2009 to that in 2011?
Provide a succinct answer. 1.06. What is the ratio of the Imports(as % of merchandise exports) of Finland in 2009 to that in 2011?
Offer a terse response. 1.11. What is the ratio of the Imports(as % of merchandise exports) of Mauritius in 2009 to that in 2011?
Your answer should be very brief. 1.12. What is the ratio of the Imports(as % of merchandise exports) of Palau in 2009 to that in 2011?
Give a very brief answer. 1.16. What is the ratio of the Imports(as % of merchandise exports) in Denmark in 2009 to that in 2012?
Provide a short and direct response. 1.06. What is the ratio of the Imports(as % of merchandise exports) of Finland in 2009 to that in 2012?
Your answer should be very brief. 1.11. What is the ratio of the Imports(as % of merchandise exports) in Mauritius in 2009 to that in 2012?
Your answer should be compact. 1.09. What is the ratio of the Imports(as % of merchandise exports) of Palau in 2009 to that in 2012?
Offer a terse response. 1.15. What is the ratio of the Imports(as % of merchandise exports) of Denmark in 2009 to that in 2013?
Keep it short and to the point. 1.08. What is the ratio of the Imports(as % of merchandise exports) of Finland in 2009 to that in 2013?
Provide a succinct answer. 1.12. What is the ratio of the Imports(as % of merchandise exports) of Mauritius in 2009 to that in 2013?
Offer a terse response. 1.12. What is the ratio of the Imports(as % of merchandise exports) of Palau in 2009 to that in 2013?
Offer a very short reply. 1.02. What is the ratio of the Imports(as % of merchandise exports) in Denmark in 2010 to that in 2011?
Offer a very short reply. 1.03. What is the ratio of the Imports(as % of merchandise exports) of Finland in 2010 to that in 2011?
Offer a terse response. 1.05. What is the ratio of the Imports(as % of merchandise exports) in Mauritius in 2010 to that in 2011?
Make the answer very short. 1.07. What is the ratio of the Imports(as % of merchandise exports) of Palau in 2010 to that in 2011?
Ensure brevity in your answer.  1.14. What is the ratio of the Imports(as % of merchandise exports) of Denmark in 2010 to that in 2012?
Your answer should be very brief. 1.04. What is the ratio of the Imports(as % of merchandise exports) in Finland in 2010 to that in 2012?
Offer a terse response. 1.05. What is the ratio of the Imports(as % of merchandise exports) of Mauritius in 2010 to that in 2012?
Make the answer very short. 1.04. What is the ratio of the Imports(as % of merchandise exports) of Palau in 2010 to that in 2012?
Your answer should be very brief. 1.13. What is the ratio of the Imports(as % of merchandise exports) of Denmark in 2010 to that in 2013?
Your response must be concise. 1.06. What is the ratio of the Imports(as % of merchandise exports) in Finland in 2010 to that in 2013?
Your answer should be compact. 1.06. What is the ratio of the Imports(as % of merchandise exports) of Mauritius in 2010 to that in 2013?
Your answer should be compact. 1.07. What is the ratio of the Imports(as % of merchandise exports) in Palau in 2010 to that in 2013?
Give a very brief answer. 1. What is the ratio of the Imports(as % of merchandise exports) in Denmark in 2011 to that in 2012?
Your answer should be compact. 1.01. What is the ratio of the Imports(as % of merchandise exports) in Finland in 2011 to that in 2012?
Your answer should be compact. 1. What is the ratio of the Imports(as % of merchandise exports) of Mauritius in 2011 to that in 2012?
Ensure brevity in your answer.  0.98. What is the ratio of the Imports(as % of merchandise exports) in Palau in 2011 to that in 2012?
Your answer should be compact. 1. What is the ratio of the Imports(as % of merchandise exports) of Denmark in 2011 to that in 2013?
Your response must be concise. 1.03. What is the ratio of the Imports(as % of merchandise exports) of Finland in 2011 to that in 2013?
Your answer should be compact. 1.01. What is the ratio of the Imports(as % of merchandise exports) in Palau in 2011 to that in 2013?
Keep it short and to the point. 0.88. What is the ratio of the Imports(as % of merchandise exports) in Denmark in 2012 to that in 2013?
Keep it short and to the point. 1.02. What is the ratio of the Imports(as % of merchandise exports) in Mauritius in 2012 to that in 2013?
Your answer should be compact. 1.03. What is the ratio of the Imports(as % of merchandise exports) of Palau in 2012 to that in 2013?
Keep it short and to the point. 0.88. What is the difference between the highest and the second highest Imports(as % of merchandise exports) in Denmark?
Give a very brief answer. 2.53. What is the difference between the highest and the second highest Imports(as % of merchandise exports) of Finland?
Your response must be concise. 1.61. What is the difference between the highest and the second highest Imports(as % of merchandise exports) in Mauritius?
Your answer should be compact. 1.33. What is the difference between the highest and the second highest Imports(as % of merchandise exports) of Palau?
Your answer should be very brief. 0.69. What is the difference between the highest and the lowest Imports(as % of merchandise exports) in Denmark?
Offer a terse response. 8.45. What is the difference between the highest and the lowest Imports(as % of merchandise exports) of Finland?
Give a very brief answer. 8.58. What is the difference between the highest and the lowest Imports(as % of merchandise exports) in Mauritius?
Provide a succinct answer. 6.32. What is the difference between the highest and the lowest Imports(as % of merchandise exports) of Palau?
Offer a very short reply. 6.19. 